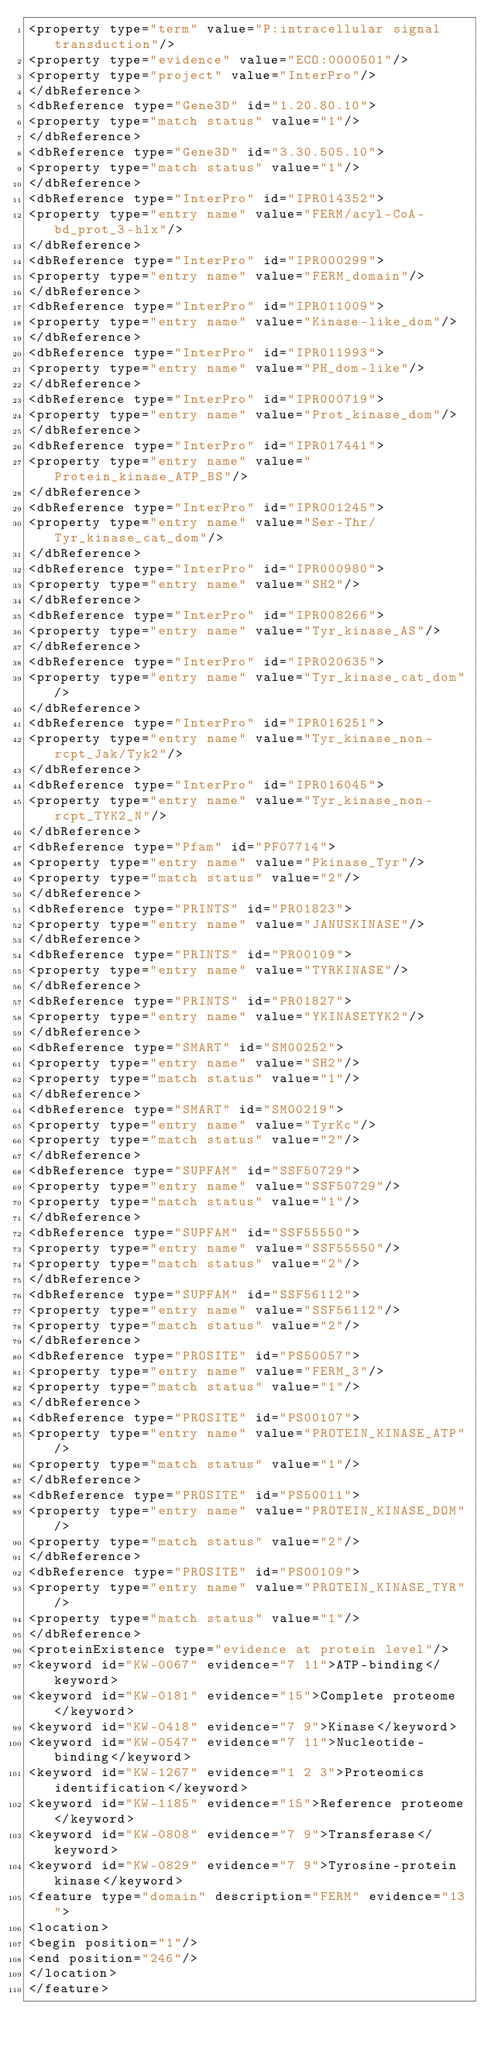<code> <loc_0><loc_0><loc_500><loc_500><_XML_><property type="term" value="P:intracellular signal transduction"/>
<property type="evidence" value="ECO:0000501"/>
<property type="project" value="InterPro"/>
</dbReference>
<dbReference type="Gene3D" id="1.20.80.10">
<property type="match status" value="1"/>
</dbReference>
<dbReference type="Gene3D" id="3.30.505.10">
<property type="match status" value="1"/>
</dbReference>
<dbReference type="InterPro" id="IPR014352">
<property type="entry name" value="FERM/acyl-CoA-bd_prot_3-hlx"/>
</dbReference>
<dbReference type="InterPro" id="IPR000299">
<property type="entry name" value="FERM_domain"/>
</dbReference>
<dbReference type="InterPro" id="IPR011009">
<property type="entry name" value="Kinase-like_dom"/>
</dbReference>
<dbReference type="InterPro" id="IPR011993">
<property type="entry name" value="PH_dom-like"/>
</dbReference>
<dbReference type="InterPro" id="IPR000719">
<property type="entry name" value="Prot_kinase_dom"/>
</dbReference>
<dbReference type="InterPro" id="IPR017441">
<property type="entry name" value="Protein_kinase_ATP_BS"/>
</dbReference>
<dbReference type="InterPro" id="IPR001245">
<property type="entry name" value="Ser-Thr/Tyr_kinase_cat_dom"/>
</dbReference>
<dbReference type="InterPro" id="IPR000980">
<property type="entry name" value="SH2"/>
</dbReference>
<dbReference type="InterPro" id="IPR008266">
<property type="entry name" value="Tyr_kinase_AS"/>
</dbReference>
<dbReference type="InterPro" id="IPR020635">
<property type="entry name" value="Tyr_kinase_cat_dom"/>
</dbReference>
<dbReference type="InterPro" id="IPR016251">
<property type="entry name" value="Tyr_kinase_non-rcpt_Jak/Tyk2"/>
</dbReference>
<dbReference type="InterPro" id="IPR016045">
<property type="entry name" value="Tyr_kinase_non-rcpt_TYK2_N"/>
</dbReference>
<dbReference type="Pfam" id="PF07714">
<property type="entry name" value="Pkinase_Tyr"/>
<property type="match status" value="2"/>
</dbReference>
<dbReference type="PRINTS" id="PR01823">
<property type="entry name" value="JANUSKINASE"/>
</dbReference>
<dbReference type="PRINTS" id="PR00109">
<property type="entry name" value="TYRKINASE"/>
</dbReference>
<dbReference type="PRINTS" id="PR01827">
<property type="entry name" value="YKINASETYK2"/>
</dbReference>
<dbReference type="SMART" id="SM00252">
<property type="entry name" value="SH2"/>
<property type="match status" value="1"/>
</dbReference>
<dbReference type="SMART" id="SM00219">
<property type="entry name" value="TyrKc"/>
<property type="match status" value="2"/>
</dbReference>
<dbReference type="SUPFAM" id="SSF50729">
<property type="entry name" value="SSF50729"/>
<property type="match status" value="1"/>
</dbReference>
<dbReference type="SUPFAM" id="SSF55550">
<property type="entry name" value="SSF55550"/>
<property type="match status" value="2"/>
</dbReference>
<dbReference type="SUPFAM" id="SSF56112">
<property type="entry name" value="SSF56112"/>
<property type="match status" value="2"/>
</dbReference>
<dbReference type="PROSITE" id="PS50057">
<property type="entry name" value="FERM_3"/>
<property type="match status" value="1"/>
</dbReference>
<dbReference type="PROSITE" id="PS00107">
<property type="entry name" value="PROTEIN_KINASE_ATP"/>
<property type="match status" value="1"/>
</dbReference>
<dbReference type="PROSITE" id="PS50011">
<property type="entry name" value="PROTEIN_KINASE_DOM"/>
<property type="match status" value="2"/>
</dbReference>
<dbReference type="PROSITE" id="PS00109">
<property type="entry name" value="PROTEIN_KINASE_TYR"/>
<property type="match status" value="1"/>
</dbReference>
<proteinExistence type="evidence at protein level"/>
<keyword id="KW-0067" evidence="7 11">ATP-binding</keyword>
<keyword id="KW-0181" evidence="15">Complete proteome</keyword>
<keyword id="KW-0418" evidence="7 9">Kinase</keyword>
<keyword id="KW-0547" evidence="7 11">Nucleotide-binding</keyword>
<keyword id="KW-1267" evidence="1 2 3">Proteomics identification</keyword>
<keyword id="KW-1185" evidence="15">Reference proteome</keyword>
<keyword id="KW-0808" evidence="7 9">Transferase</keyword>
<keyword id="KW-0829" evidence="7 9">Tyrosine-protein kinase</keyword>
<feature type="domain" description="FERM" evidence="13">
<location>
<begin position="1"/>
<end position="246"/>
</location>
</feature></code> 